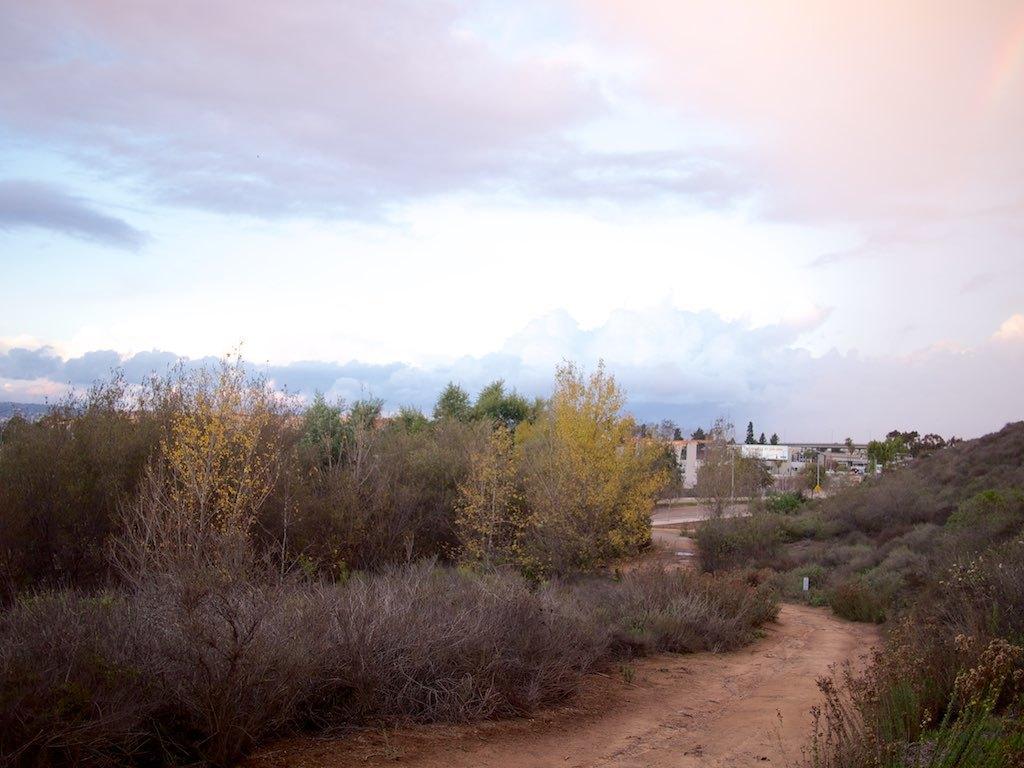Please provide a concise description of this image. In this image I can see few trees in green color. In the background I can see few buildings and the sky is in blue and white color. 